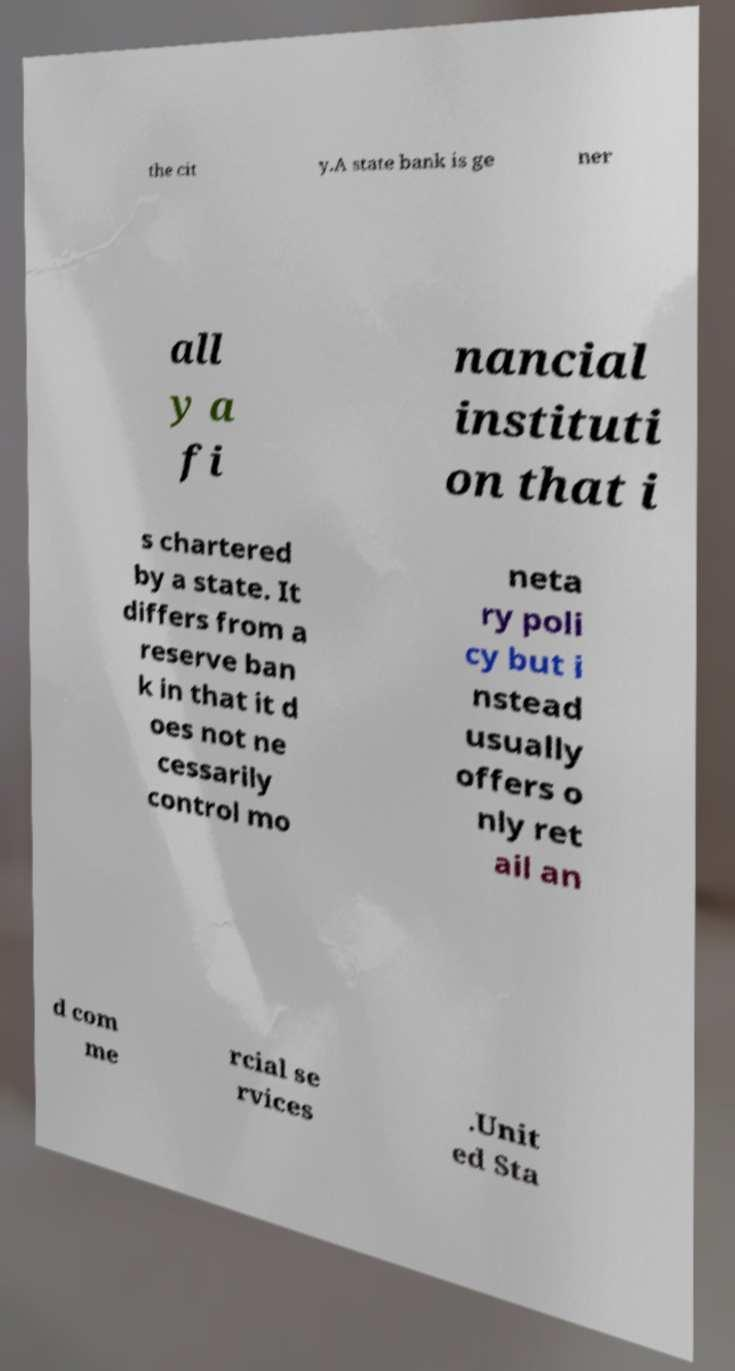Please read and relay the text visible in this image. What does it say? the cit y.A state bank is ge ner all y a fi nancial instituti on that i s chartered by a state. It differs from a reserve ban k in that it d oes not ne cessarily control mo neta ry poli cy but i nstead usually offers o nly ret ail an d com me rcial se rvices .Unit ed Sta 